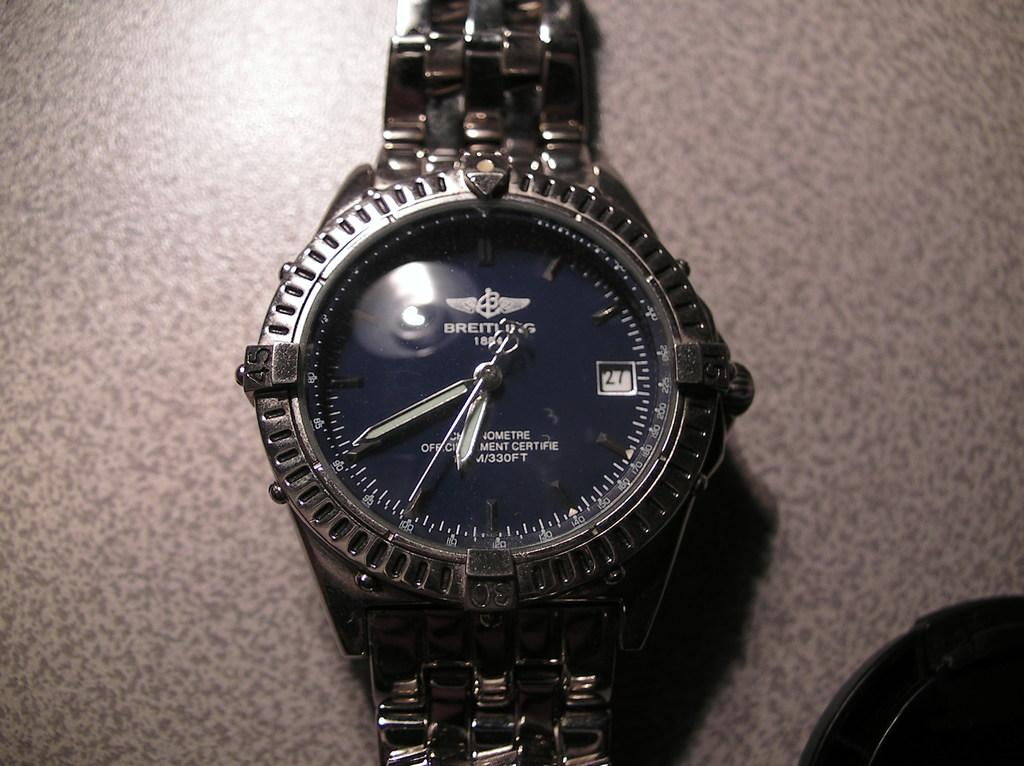<image>
Render a clear and concise summary of the photo. A black and gold watch that says Breiting on the watch face. 